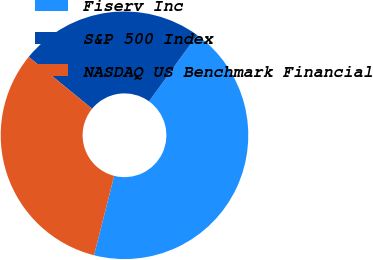<chart> <loc_0><loc_0><loc_500><loc_500><pie_chart><fcel>Fiserv Inc<fcel>S&P 500 Index<fcel>NASDAQ US Benchmark Financial<nl><fcel>43.99%<fcel>24.06%<fcel>31.96%<nl></chart> 